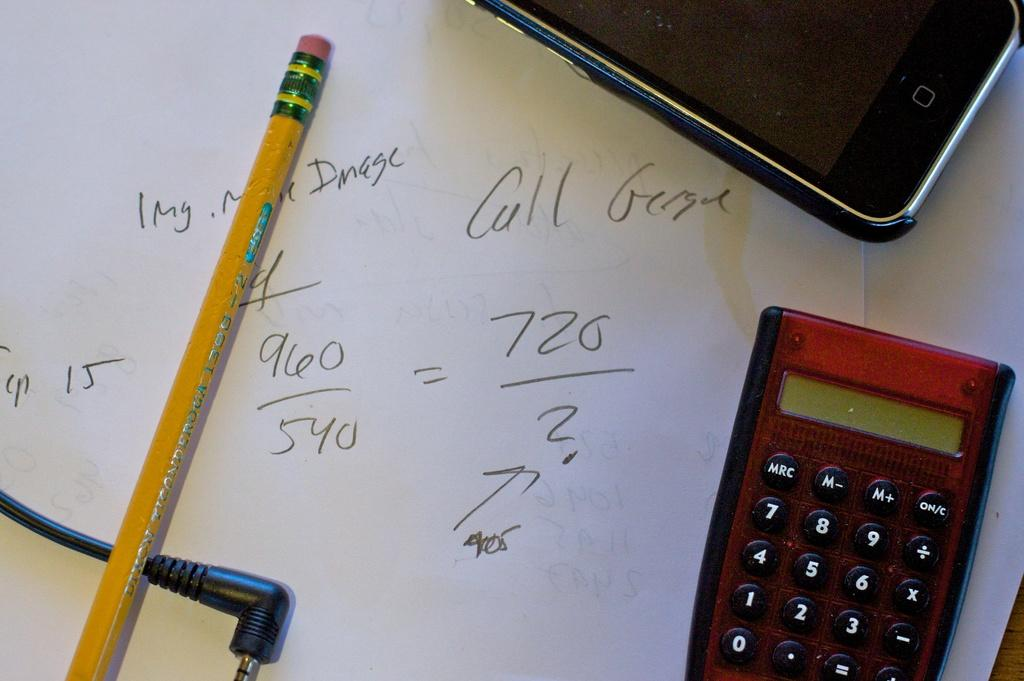Provide a one-sentence caption for the provided image. Red calculator on top of a piece of paper that says "Call George". 